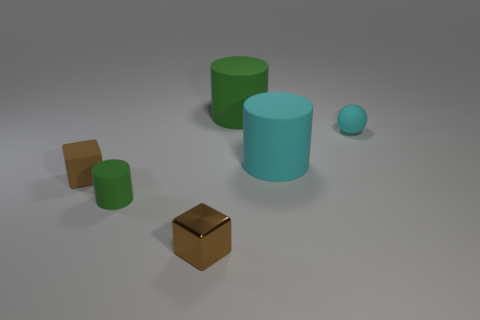Add 3 red matte objects. How many objects exist? 9 Subtract all balls. How many objects are left? 5 Subtract 0 yellow cubes. How many objects are left? 6 Subtract all small brown rubber blocks. Subtract all small green matte cylinders. How many objects are left? 4 Add 3 cyan cylinders. How many cyan cylinders are left? 4 Add 1 brown blocks. How many brown blocks exist? 3 